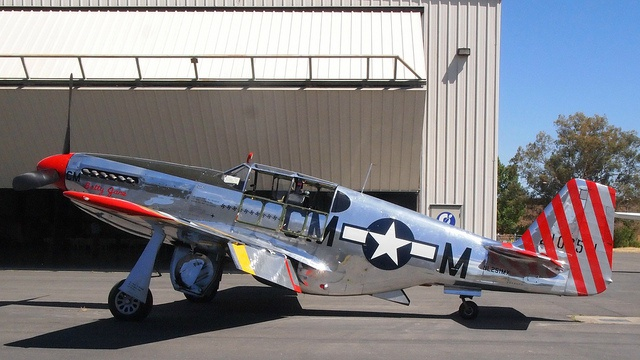Describe the objects in this image and their specific colors. I can see airplane in lightgray, gray, black, and darkgray tones and people in lightgray, black, gray, and maroon tones in this image. 